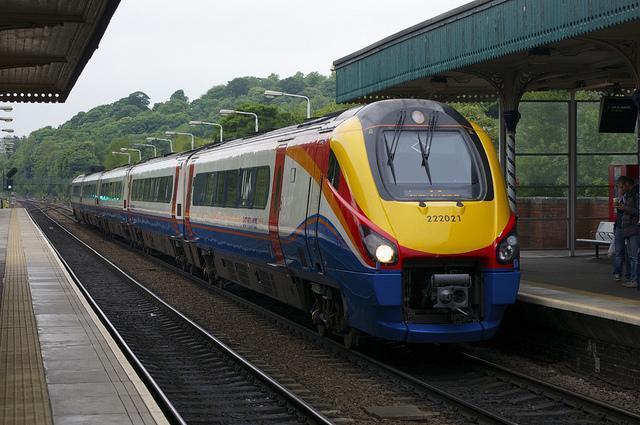How many headlights are on?
Give a very brief answer. 1. 